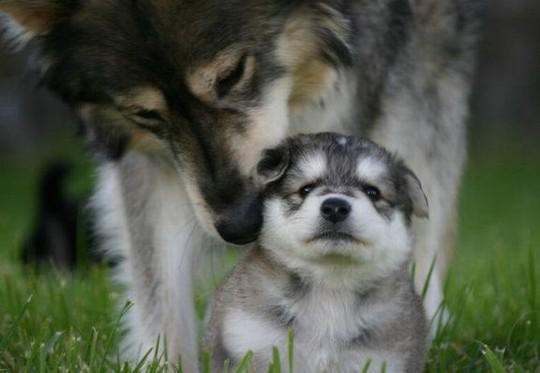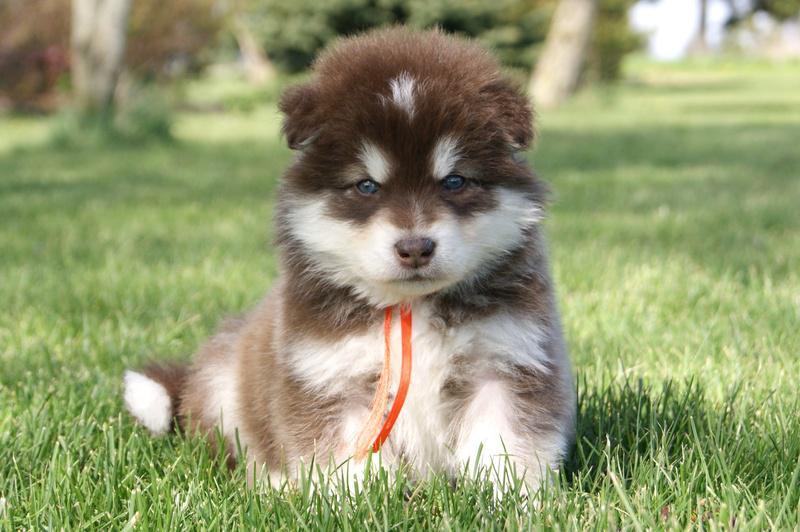The first image is the image on the left, the second image is the image on the right. Given the left and right images, does the statement "There are three Husky dogs." hold true? Answer yes or no. Yes. The first image is the image on the left, the second image is the image on the right. Analyze the images presented: Is the assertion "There is a total of three dogs in both images." valid? Answer yes or no. Yes. 